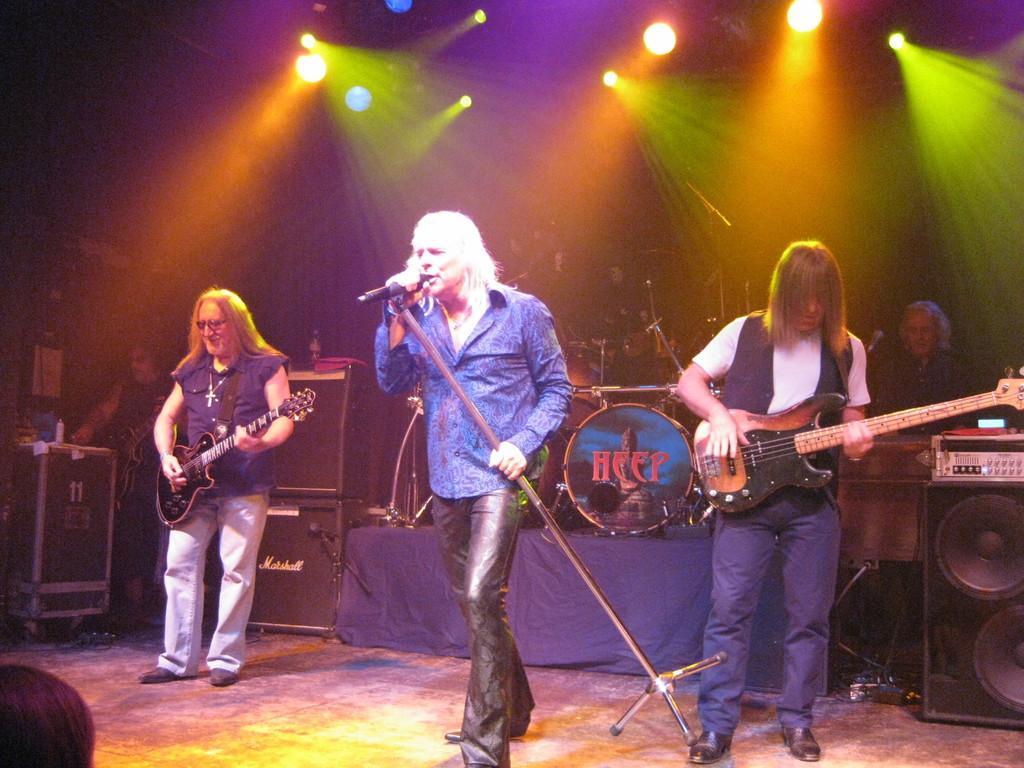Can you describe this image briefly? There are three persons standing on the floor. These two are playing guitar and he is singing on the mike. There are some musical instruments and these are the lights. 